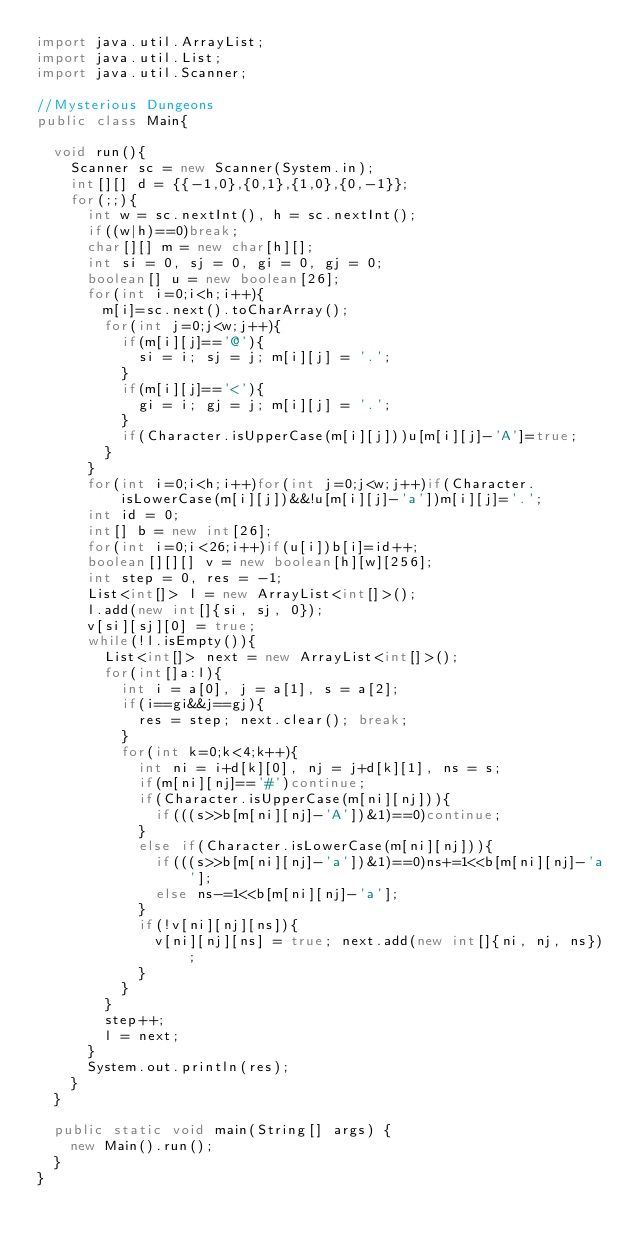<code> <loc_0><loc_0><loc_500><loc_500><_Java_>import java.util.ArrayList;
import java.util.List;
import java.util.Scanner;

//Mysterious Dungeons
public class Main{

	void run(){
		Scanner sc = new Scanner(System.in);
		int[][] d = {{-1,0},{0,1},{1,0},{0,-1}};
		for(;;){
			int w = sc.nextInt(), h = sc.nextInt();
			if((w|h)==0)break;
			char[][] m = new char[h][];
			int si = 0, sj = 0, gi = 0, gj = 0;
			boolean[] u = new boolean[26];
			for(int i=0;i<h;i++){
				m[i]=sc.next().toCharArray();
				for(int j=0;j<w;j++){
					if(m[i][j]=='@'){
						si = i; sj = j; m[i][j] = '.';
					}
					if(m[i][j]=='<'){
						gi = i; gj = j; m[i][j] = '.';
					}
					if(Character.isUpperCase(m[i][j]))u[m[i][j]-'A']=true;
				}
			}
			for(int i=0;i<h;i++)for(int j=0;j<w;j++)if(Character.isLowerCase(m[i][j])&&!u[m[i][j]-'a'])m[i][j]='.';
			int id = 0;
			int[] b = new int[26];
			for(int i=0;i<26;i++)if(u[i])b[i]=id++;
			boolean[][][] v = new boolean[h][w][256];
			int step = 0, res = -1;
			List<int[]> l = new ArrayList<int[]>();
			l.add(new int[]{si, sj, 0});
			v[si][sj][0] = true;
			while(!l.isEmpty()){
				List<int[]> next = new ArrayList<int[]>();
				for(int[]a:l){
					int i = a[0], j = a[1], s = a[2];
					if(i==gi&&j==gj){
						res = step; next.clear(); break;
					}
					for(int k=0;k<4;k++){
						int ni = i+d[k][0], nj = j+d[k][1], ns = s;
						if(m[ni][nj]=='#')continue;
						if(Character.isUpperCase(m[ni][nj])){
							if(((s>>b[m[ni][nj]-'A'])&1)==0)continue;
						}
						else if(Character.isLowerCase(m[ni][nj])){
							if(((s>>b[m[ni][nj]-'a'])&1)==0)ns+=1<<b[m[ni][nj]-'a'];
							else ns-=1<<b[m[ni][nj]-'a'];
						}
						if(!v[ni][nj][ns]){
							v[ni][nj][ns] = true; next.add(new int[]{ni, nj, ns});
						}
					}
				}
				step++;
				l = next;
			}
			System.out.println(res);
		}
	}
	
	public static void main(String[] args) {
		new Main().run();
	}
}</code> 